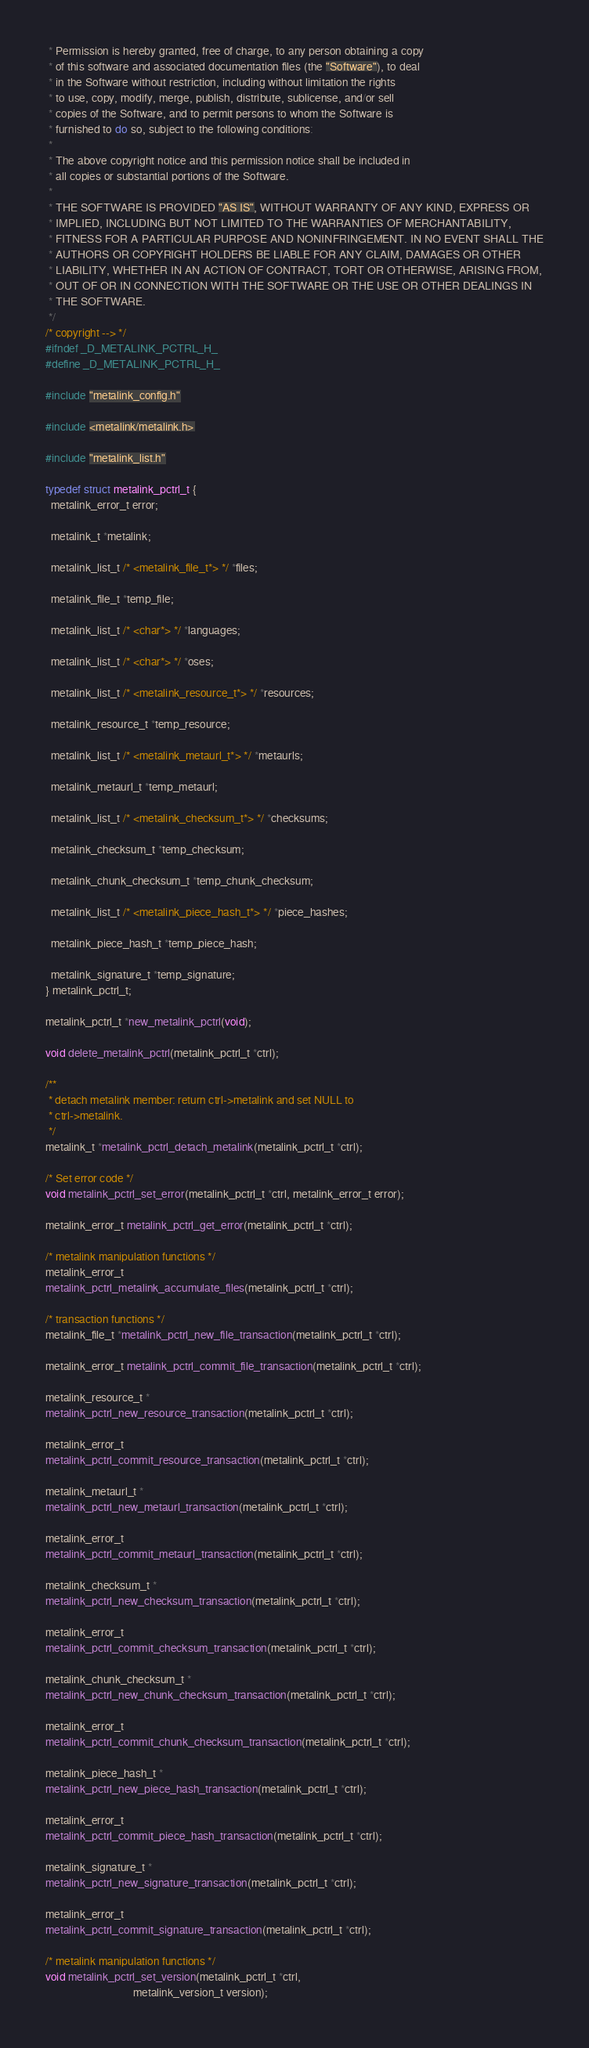Convert code to text. <code><loc_0><loc_0><loc_500><loc_500><_C_> * Permission is hereby granted, free of charge, to any person obtaining a copy
 * of this software and associated documentation files (the "Software"), to deal
 * in the Software without restriction, including without limitation the rights
 * to use, copy, modify, merge, publish, distribute, sublicense, and/or sell
 * copies of the Software, and to permit persons to whom the Software is
 * furnished to do so, subject to the following conditions:
 *
 * The above copyright notice and this permission notice shall be included in
 * all copies or substantial portions of the Software.
 *
 * THE SOFTWARE IS PROVIDED "AS IS", WITHOUT WARRANTY OF ANY KIND, EXPRESS OR
 * IMPLIED, INCLUDING BUT NOT LIMITED TO THE WARRANTIES OF MERCHANTABILITY,
 * FITNESS FOR A PARTICULAR PURPOSE AND NONINFRINGEMENT. IN NO EVENT SHALL THE
 * AUTHORS OR COPYRIGHT HOLDERS BE LIABLE FOR ANY CLAIM, DAMAGES OR OTHER
 * LIABILITY, WHETHER IN AN ACTION OF CONTRACT, TORT OR OTHERWISE, ARISING FROM,
 * OUT OF OR IN CONNECTION WITH THE SOFTWARE OR THE USE OR OTHER DEALINGS IN
 * THE SOFTWARE.
 */
/* copyright --> */
#ifndef _D_METALINK_PCTRL_H_
#define _D_METALINK_PCTRL_H_

#include "metalink_config.h"

#include <metalink/metalink.h>

#include "metalink_list.h"

typedef struct metalink_pctrl_t {
  metalink_error_t error;

  metalink_t *metalink;

  metalink_list_t /* <metalink_file_t*> */ *files;

  metalink_file_t *temp_file;

  metalink_list_t /* <char*> */ *languages;

  metalink_list_t /* <char*> */ *oses;

  metalink_list_t /* <metalink_resource_t*> */ *resources;

  metalink_resource_t *temp_resource;

  metalink_list_t /* <metalink_metaurl_t*> */ *metaurls;

  metalink_metaurl_t *temp_metaurl;

  metalink_list_t /* <metalink_checksum_t*> */ *checksums;

  metalink_checksum_t *temp_checksum;

  metalink_chunk_checksum_t *temp_chunk_checksum;

  metalink_list_t /* <metalink_piece_hash_t*> */ *piece_hashes;

  metalink_piece_hash_t *temp_piece_hash;

  metalink_signature_t *temp_signature;
} metalink_pctrl_t;

metalink_pctrl_t *new_metalink_pctrl(void);

void delete_metalink_pctrl(metalink_pctrl_t *ctrl);

/**
 * detach metalink member: return ctrl->metalink and set NULL to
 * ctrl->metalink.
 */
metalink_t *metalink_pctrl_detach_metalink(metalink_pctrl_t *ctrl);

/* Set error code */
void metalink_pctrl_set_error(metalink_pctrl_t *ctrl, metalink_error_t error);

metalink_error_t metalink_pctrl_get_error(metalink_pctrl_t *ctrl);

/* metalink manipulation functions */
metalink_error_t
metalink_pctrl_metalink_accumulate_files(metalink_pctrl_t *ctrl);

/* transaction functions */
metalink_file_t *metalink_pctrl_new_file_transaction(metalink_pctrl_t *ctrl);

metalink_error_t metalink_pctrl_commit_file_transaction(metalink_pctrl_t *ctrl);

metalink_resource_t *
metalink_pctrl_new_resource_transaction(metalink_pctrl_t *ctrl);

metalink_error_t
metalink_pctrl_commit_resource_transaction(metalink_pctrl_t *ctrl);

metalink_metaurl_t *
metalink_pctrl_new_metaurl_transaction(metalink_pctrl_t *ctrl);

metalink_error_t
metalink_pctrl_commit_metaurl_transaction(metalink_pctrl_t *ctrl);

metalink_checksum_t *
metalink_pctrl_new_checksum_transaction(metalink_pctrl_t *ctrl);

metalink_error_t
metalink_pctrl_commit_checksum_transaction(metalink_pctrl_t *ctrl);

metalink_chunk_checksum_t *
metalink_pctrl_new_chunk_checksum_transaction(metalink_pctrl_t *ctrl);

metalink_error_t
metalink_pctrl_commit_chunk_checksum_transaction(metalink_pctrl_t *ctrl);

metalink_piece_hash_t *
metalink_pctrl_new_piece_hash_transaction(metalink_pctrl_t *ctrl);

metalink_error_t
metalink_pctrl_commit_piece_hash_transaction(metalink_pctrl_t *ctrl);

metalink_signature_t *
metalink_pctrl_new_signature_transaction(metalink_pctrl_t *ctrl);

metalink_error_t
metalink_pctrl_commit_signature_transaction(metalink_pctrl_t *ctrl);

/* metalink manipulation functions */
void metalink_pctrl_set_version(metalink_pctrl_t *ctrl,
                                metalink_version_t version);</code> 